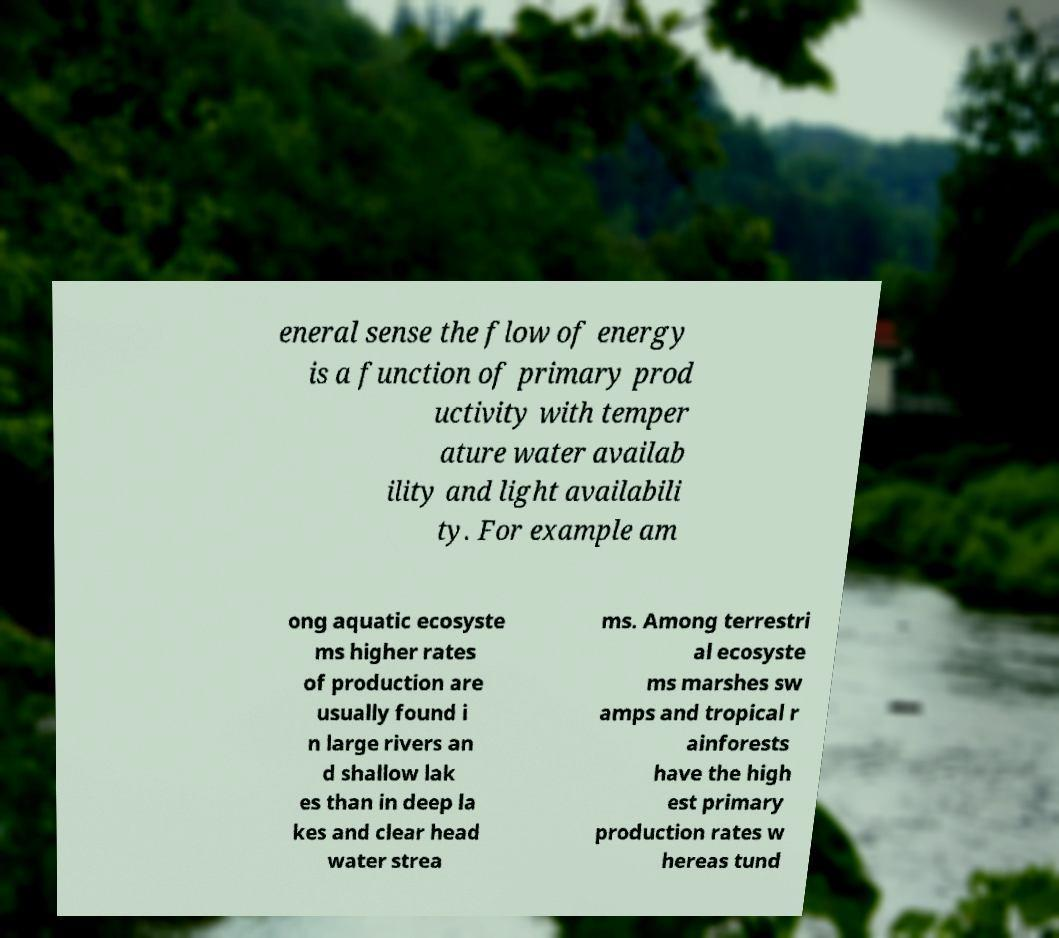Please identify and transcribe the text found in this image. eneral sense the flow of energy is a function of primary prod uctivity with temper ature water availab ility and light availabili ty. For example am ong aquatic ecosyste ms higher rates of production are usually found i n large rivers an d shallow lak es than in deep la kes and clear head water strea ms. Among terrestri al ecosyste ms marshes sw amps and tropical r ainforests have the high est primary production rates w hereas tund 